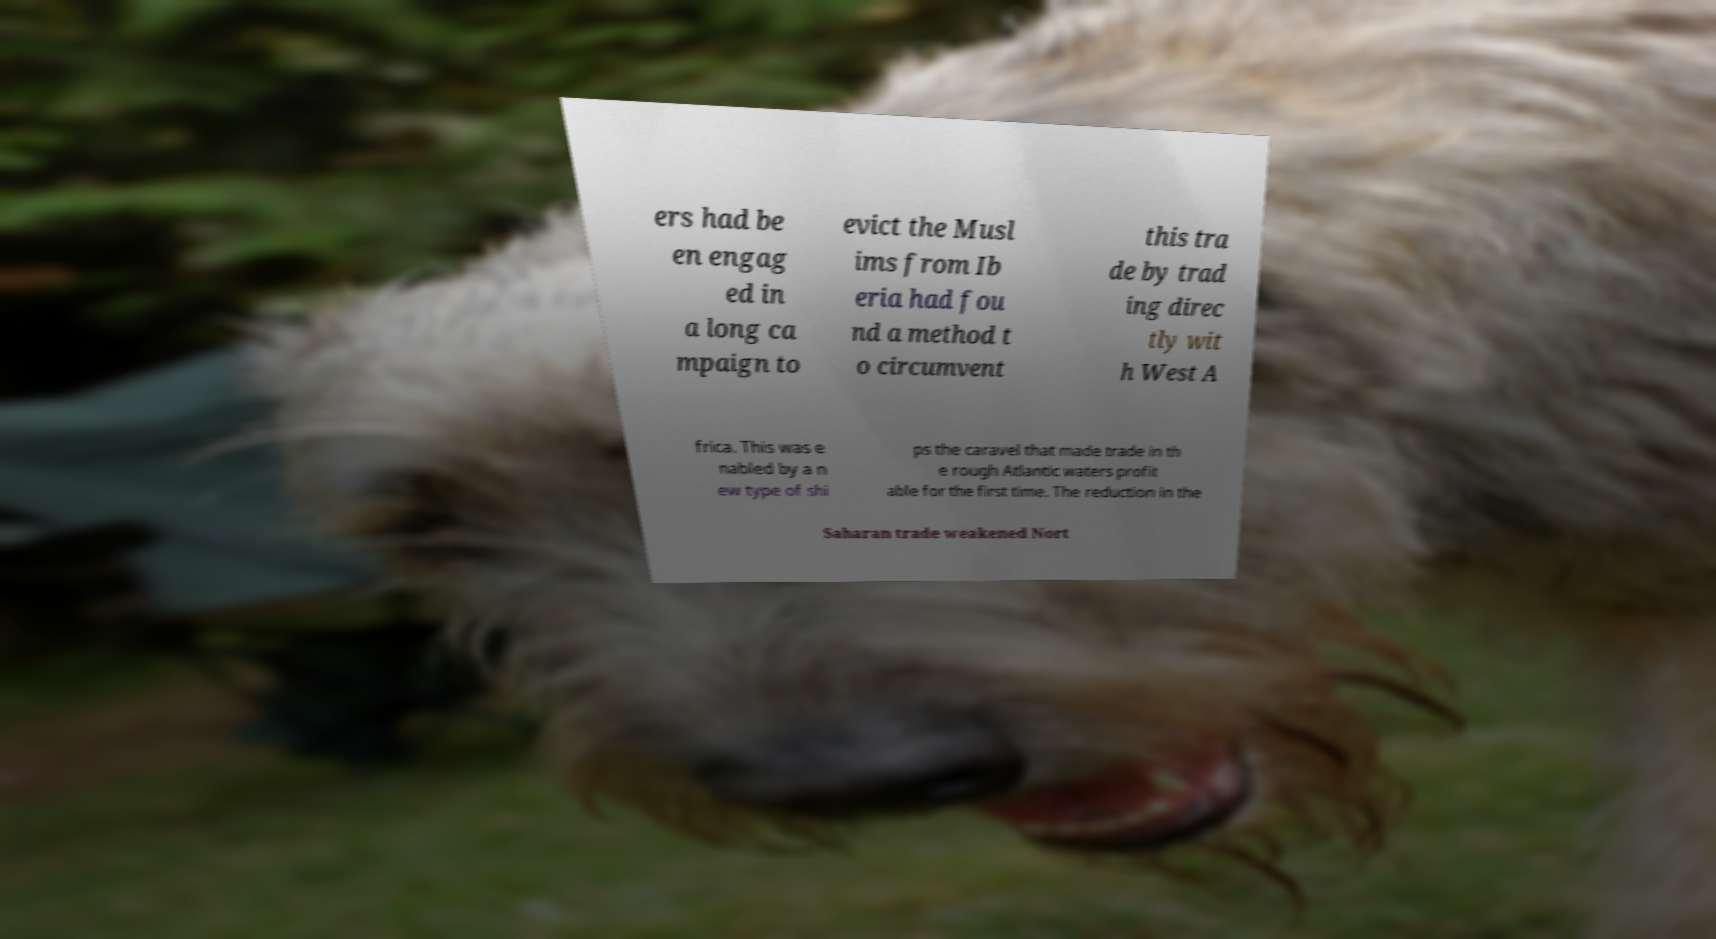For documentation purposes, I need the text within this image transcribed. Could you provide that? ers had be en engag ed in a long ca mpaign to evict the Musl ims from Ib eria had fou nd a method t o circumvent this tra de by trad ing direc tly wit h West A frica. This was e nabled by a n ew type of shi ps the caravel that made trade in th e rough Atlantic waters profit able for the first time. The reduction in the Saharan trade weakened Nort 